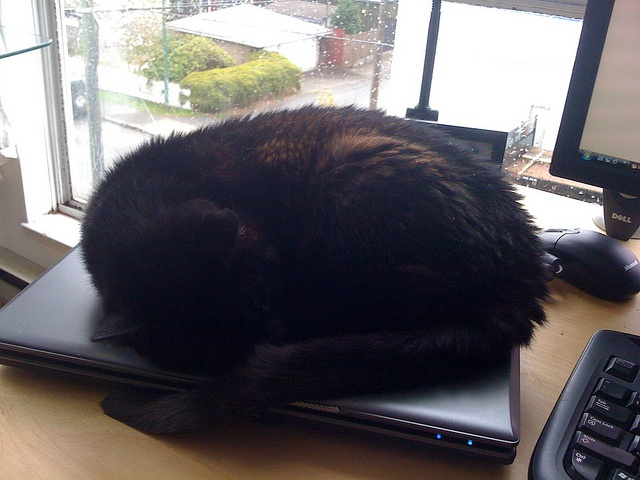Describe the objects in this image and their specific colors. I can see cat in lightgray, black, and gray tones, laptop in lightgray, black, darkgray, and gray tones, tv in lightgray, darkgray, black, and darkblue tones, keyboard in lightgray, black, and gray tones, and mouse in lightgray, black, gray, darkgray, and lavender tones in this image. 